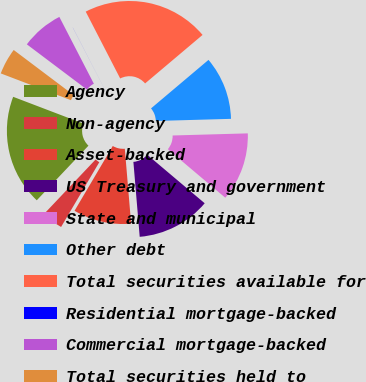<chart> <loc_0><loc_0><loc_500><loc_500><pie_chart><fcel>Agency<fcel>Non-agency<fcel>Asset-backed<fcel>US Treasury and government<fcel>State and municipal<fcel>Other debt<fcel>Total securities available for<fcel>Residential mortgage-backed<fcel>Commercial mortgage-backed<fcel>Total securities held to<nl><fcel>18.74%<fcel>3.58%<fcel>9.82%<fcel>12.5%<fcel>11.61%<fcel>10.71%<fcel>21.42%<fcel>0.01%<fcel>7.14%<fcel>4.47%<nl></chart> 